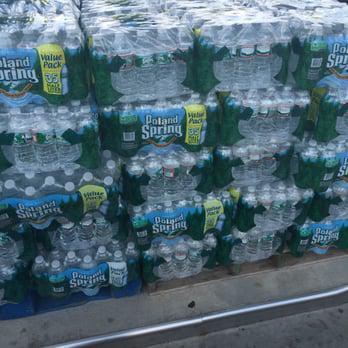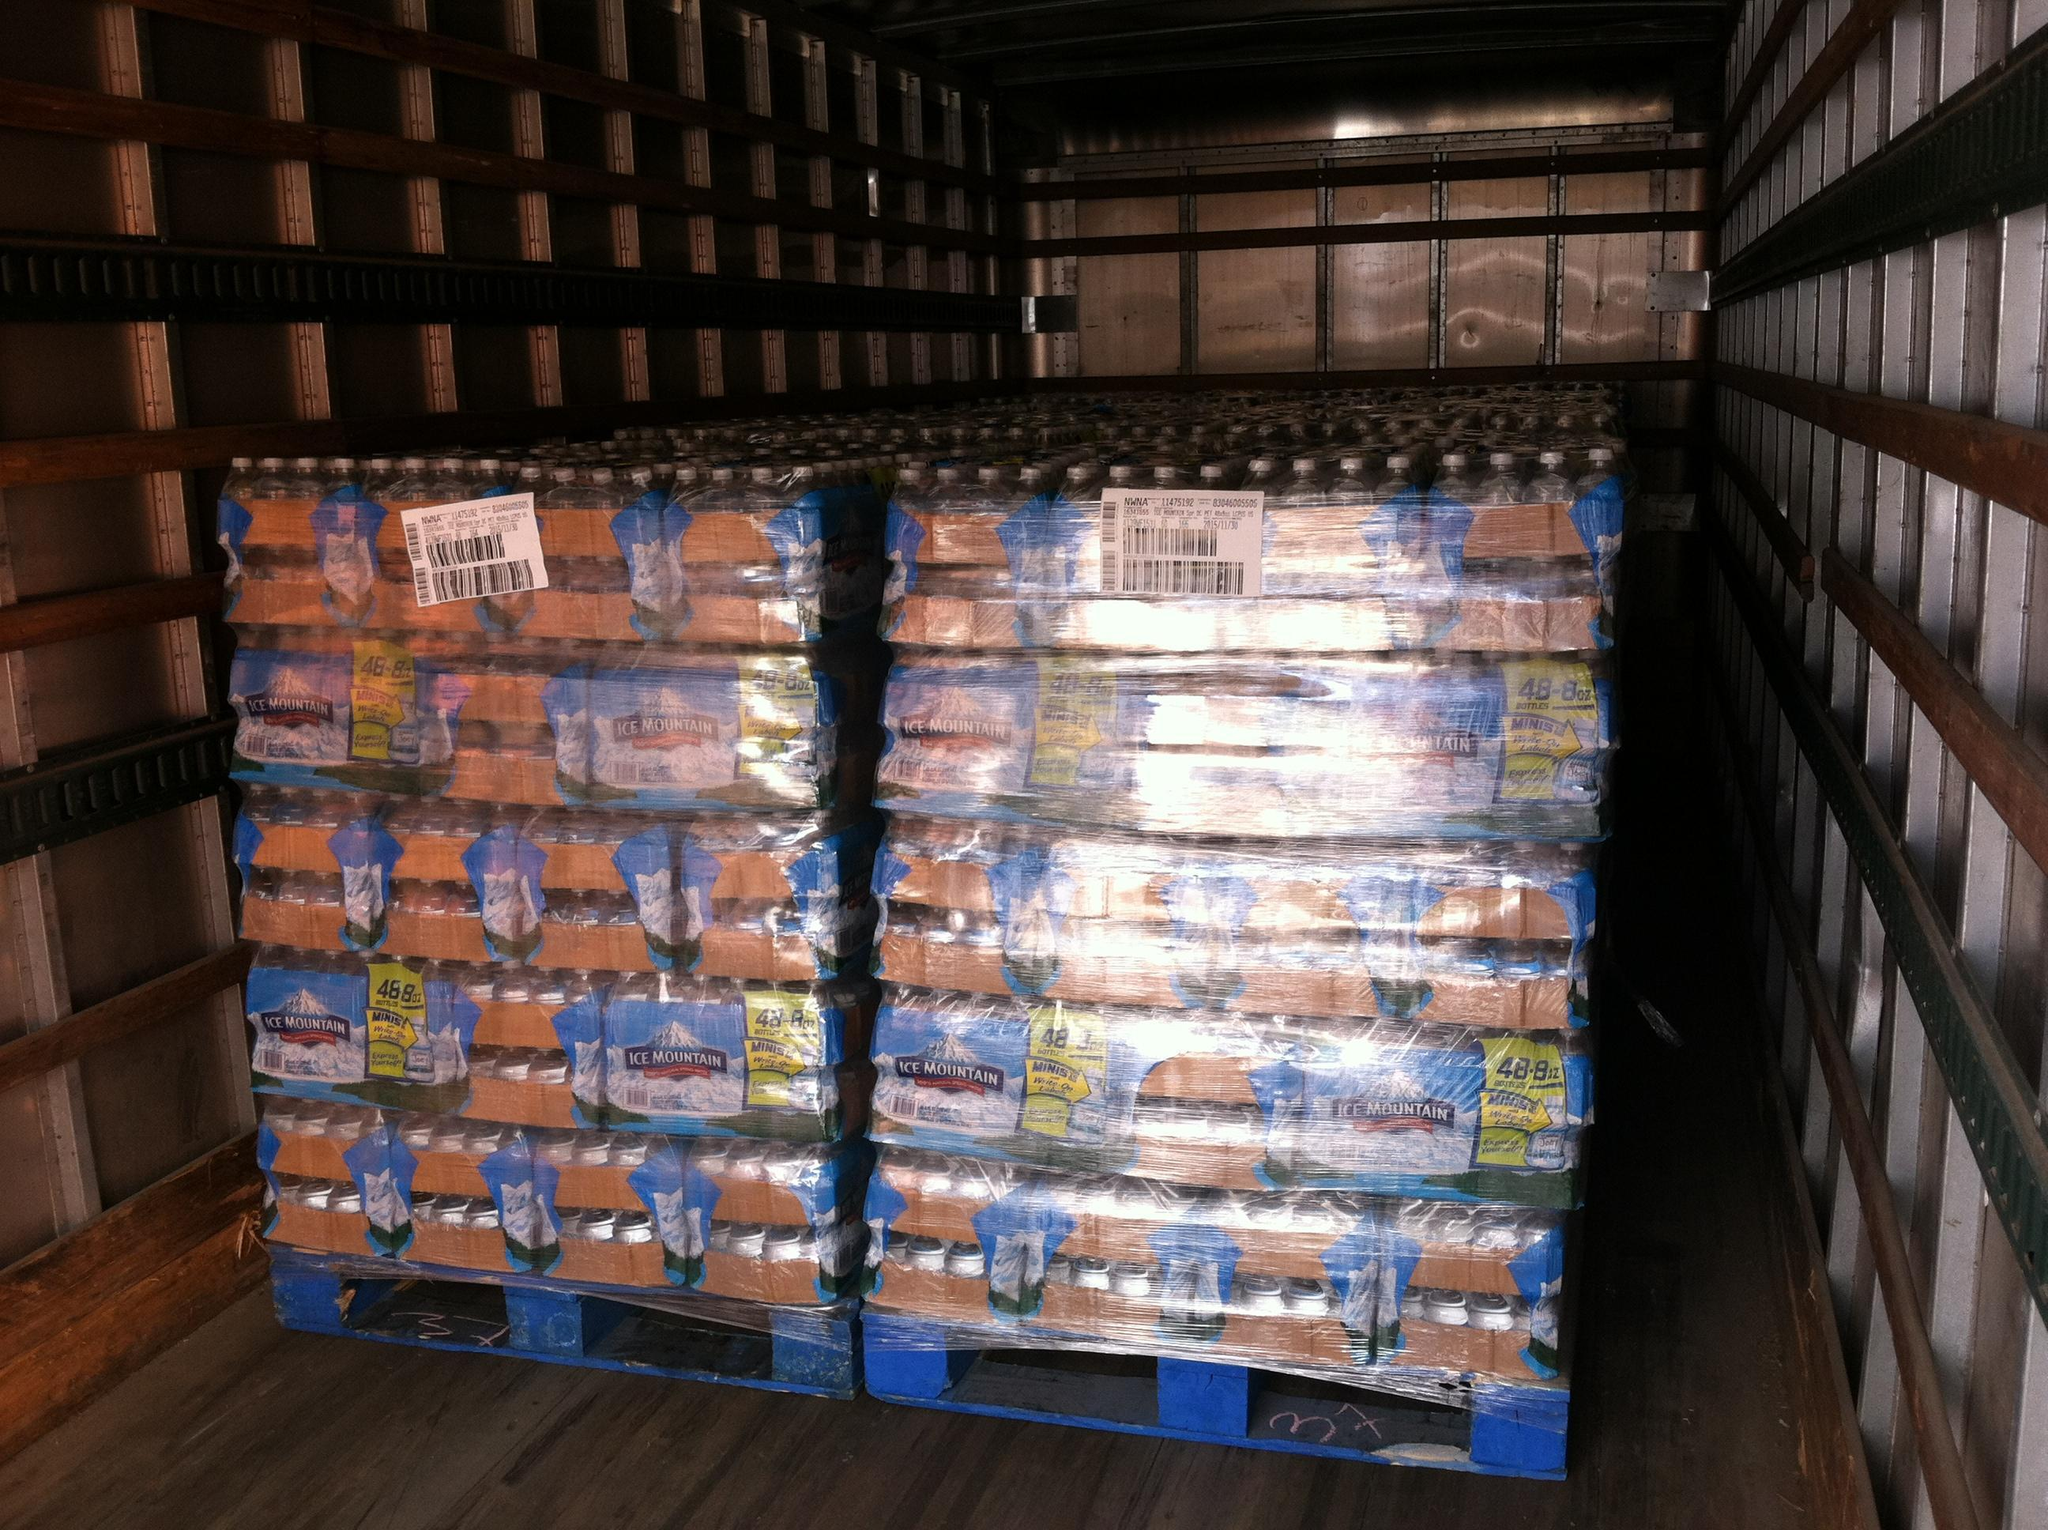The first image is the image on the left, the second image is the image on the right. Analyze the images presented: Is the assertion "There are exactly three shelves of water bottles in the image on the left." valid? Answer yes or no. No. 